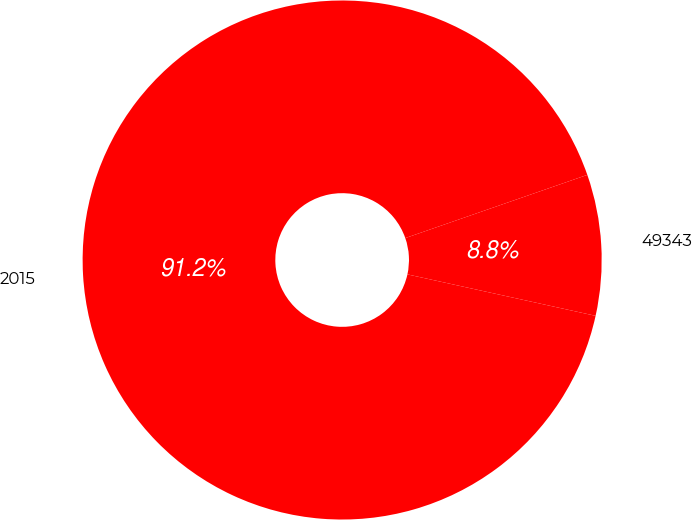Convert chart to OTSL. <chart><loc_0><loc_0><loc_500><loc_500><pie_chart><fcel>2015<fcel>49343<nl><fcel>91.23%<fcel>8.77%<nl></chart> 